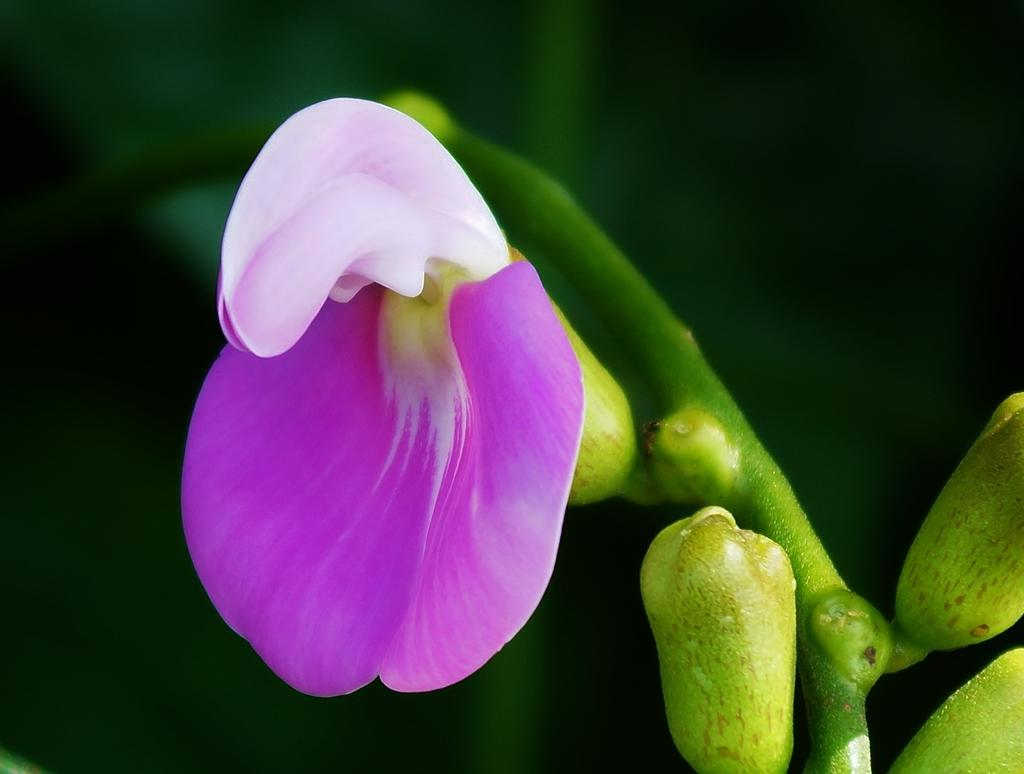Where was the image taken? The image was taken outdoors. How would you describe the lighting in the image? The background of the image is a little dark. What can be seen on the right side of the image? There is a plant on the right side of the image. Can you describe the plant in the image? The plant has leaves, stems, buds, and a flower. Is there any money visible in the image? No, there is no money visible in the image. Can you see a gun in the image? No, there is no gun present in the image. 